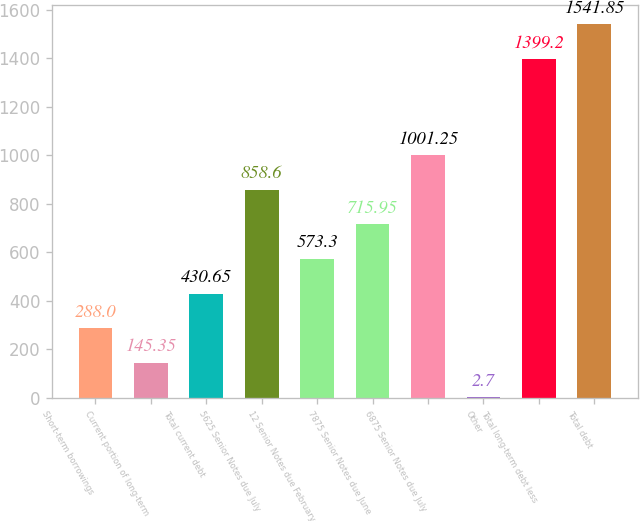Convert chart to OTSL. <chart><loc_0><loc_0><loc_500><loc_500><bar_chart><fcel>Short-term borrowings<fcel>Current portion of long-term<fcel>Total current debt<fcel>5625 Senior Notes due July<fcel>12 Senior Notes due February<fcel>7875 Senior Notes due June<fcel>6875 Senior Notes due July<fcel>Other<fcel>Total long-term debt less<fcel>Total debt<nl><fcel>288<fcel>145.35<fcel>430.65<fcel>858.6<fcel>573.3<fcel>715.95<fcel>1001.25<fcel>2.7<fcel>1399.2<fcel>1541.85<nl></chart> 